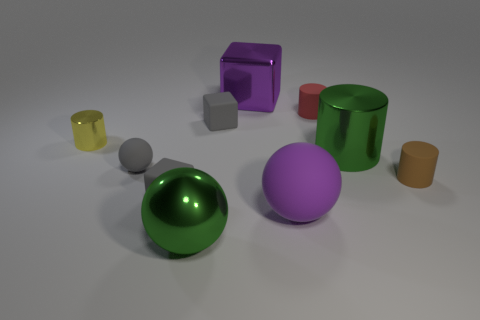There is a large metal thing that is the same color as the big metallic ball; what is its shape?
Your answer should be very brief. Cylinder. Are there any large green metallic things that have the same shape as the purple shiny object?
Provide a succinct answer. No. The matte thing that is the same size as the purple cube is what color?
Offer a terse response. Purple. How many objects are either green metallic things that are left of the big cube or big green metal objects that are in front of the metal cube?
Provide a succinct answer. 2. What number of objects are either yellow balls or large green metal objects?
Make the answer very short. 2. What is the size of the sphere that is both on the left side of the purple metallic thing and in front of the brown cylinder?
Offer a very short reply. Large. What number of small purple blocks have the same material as the big green ball?
Your answer should be very brief. 0. There is a big object that is the same material as the tiny gray ball; what color is it?
Ensure brevity in your answer.  Purple. Do the rubber sphere to the right of the big green sphere and the tiny matte ball have the same color?
Ensure brevity in your answer.  No. There is a gray thing that is on the right side of the big green metallic ball; what is it made of?
Provide a succinct answer. Rubber. 